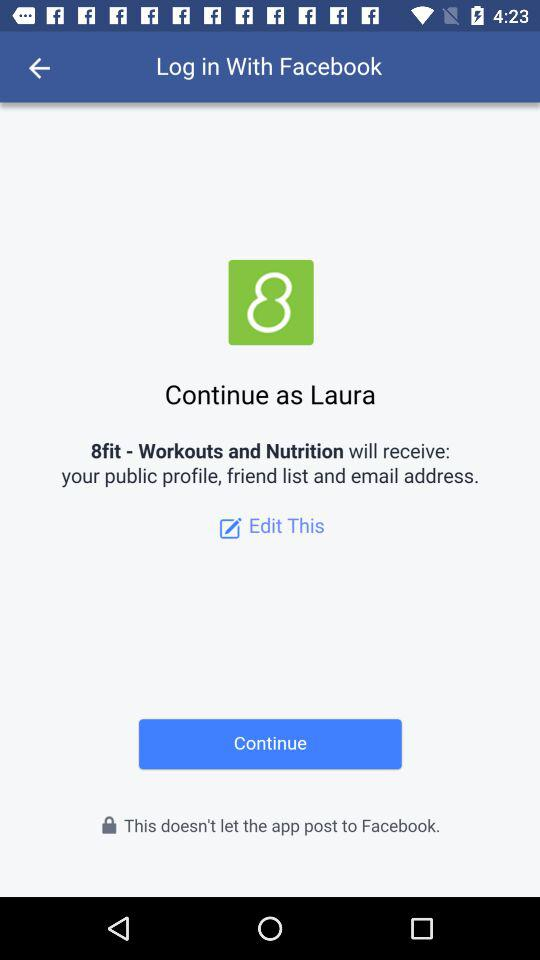What application can I use to log in to the profile? You can use "Facebook" to log in to the profile. 